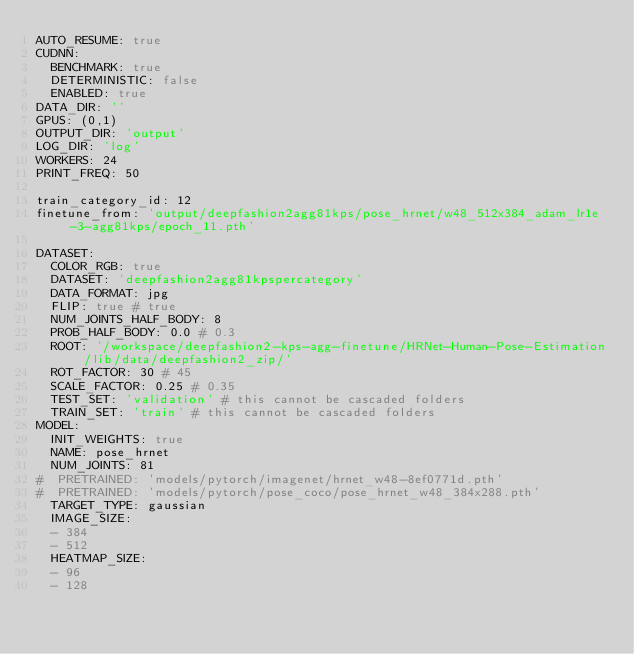<code> <loc_0><loc_0><loc_500><loc_500><_YAML_>AUTO_RESUME: true
CUDNN:
  BENCHMARK: true
  DETERMINISTIC: false
  ENABLED: true
DATA_DIR: ''
GPUS: (0,1)
OUTPUT_DIR: 'output'
LOG_DIR: 'log'
WORKERS: 24
PRINT_FREQ: 50

train_category_id: 12
finetune_from: 'output/deepfashion2agg81kps/pose_hrnet/w48_512x384_adam_lr1e-3-agg81kps/epoch_11.pth'

DATASET:
  COLOR_RGB: true
  DATASET: 'deepfashion2agg81kpspercategory'
  DATA_FORMAT: jpg
  FLIP: true # true
  NUM_JOINTS_HALF_BODY: 8
  PROB_HALF_BODY: 0.0 # 0.3
  ROOT: '/workspace/deepfashion2-kps-agg-finetune/HRNet-Human-Pose-Estimation/lib/data/deepfashion2_zip/'
  ROT_FACTOR: 30 # 45
  SCALE_FACTOR: 0.25 # 0.35
  TEST_SET: 'validation' # this cannot be cascaded folders
  TRAIN_SET: 'train' # this cannot be cascaded folders
MODEL:
  INIT_WEIGHTS: true
  NAME: pose_hrnet
  NUM_JOINTS: 81
#  PRETRAINED: 'models/pytorch/imagenet/hrnet_w48-8ef0771d.pth'
#  PRETRAINED: 'models/pytorch/pose_coco/pose_hrnet_w48_384x288.pth'
  TARGET_TYPE: gaussian
  IMAGE_SIZE:
  - 384
  - 512
  HEATMAP_SIZE:
  - 96
  - 128</code> 